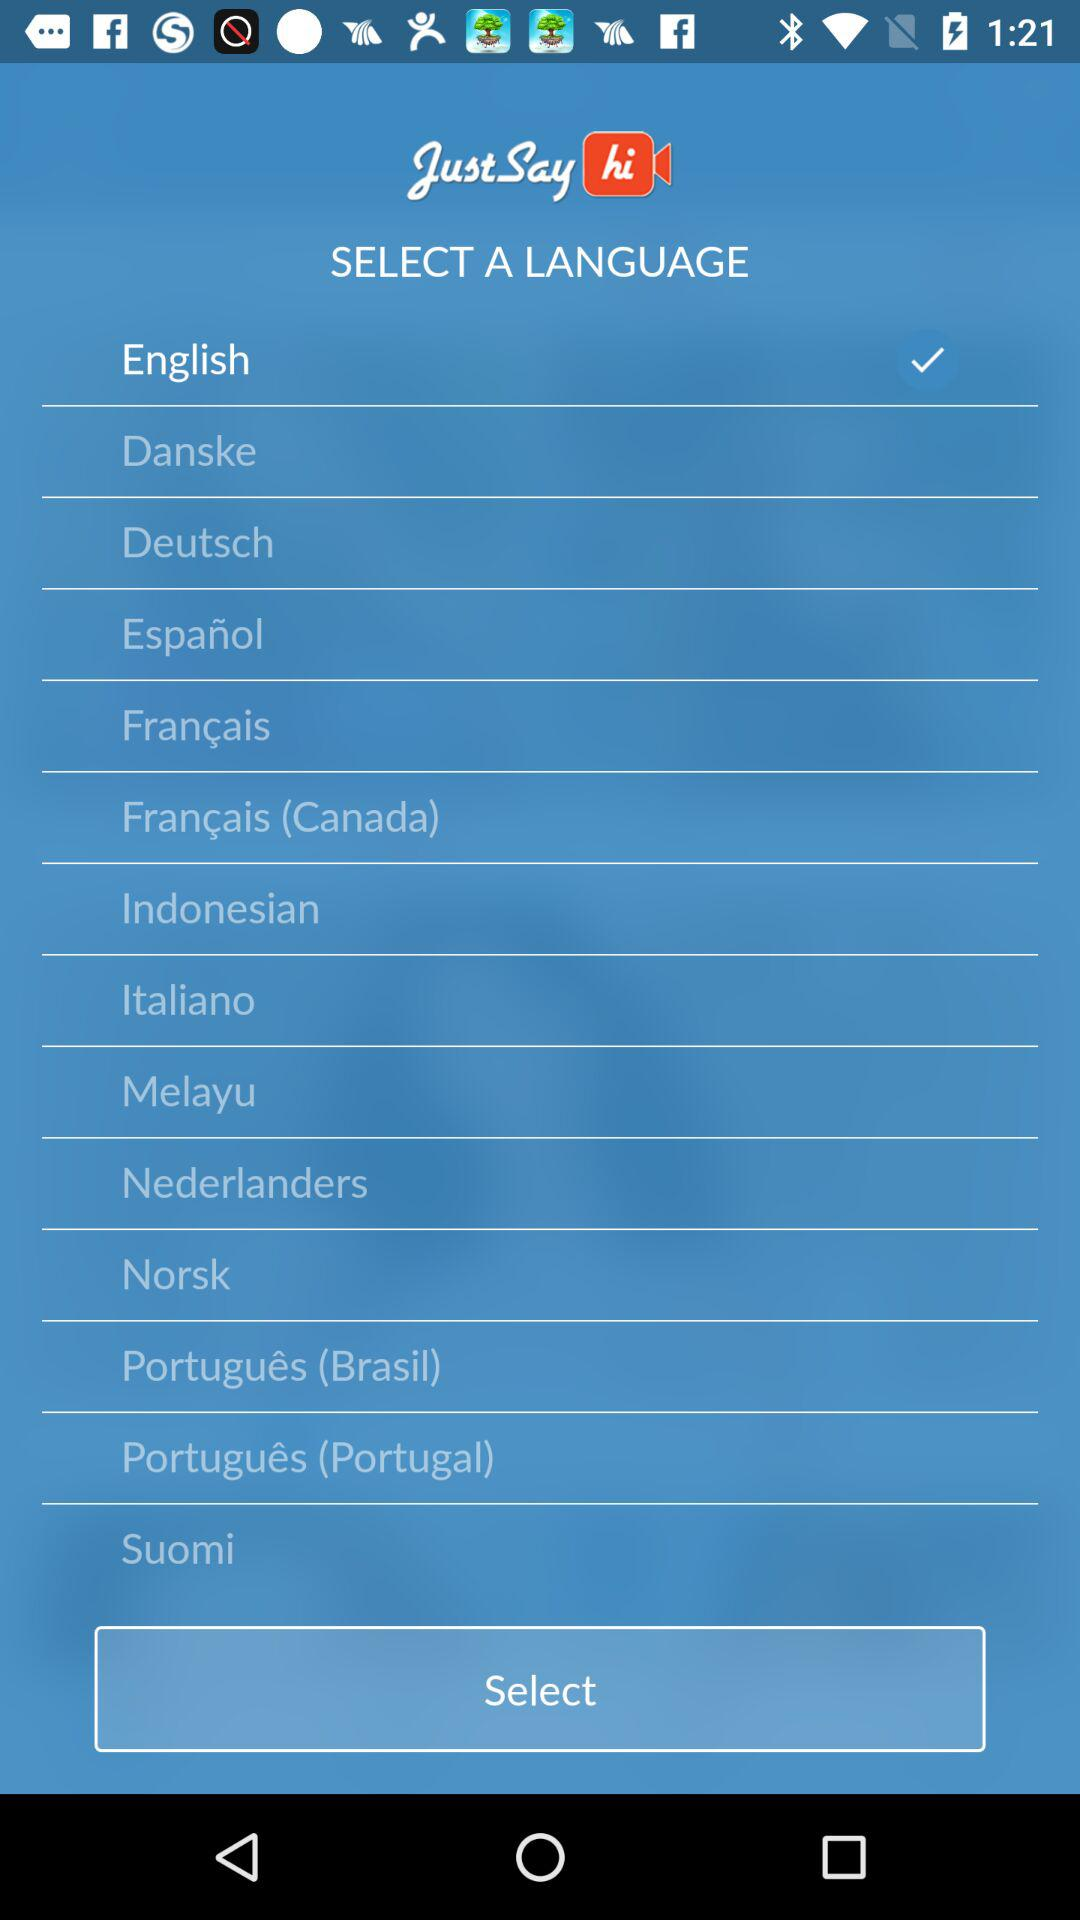Which option is selected? The selected option is English. 